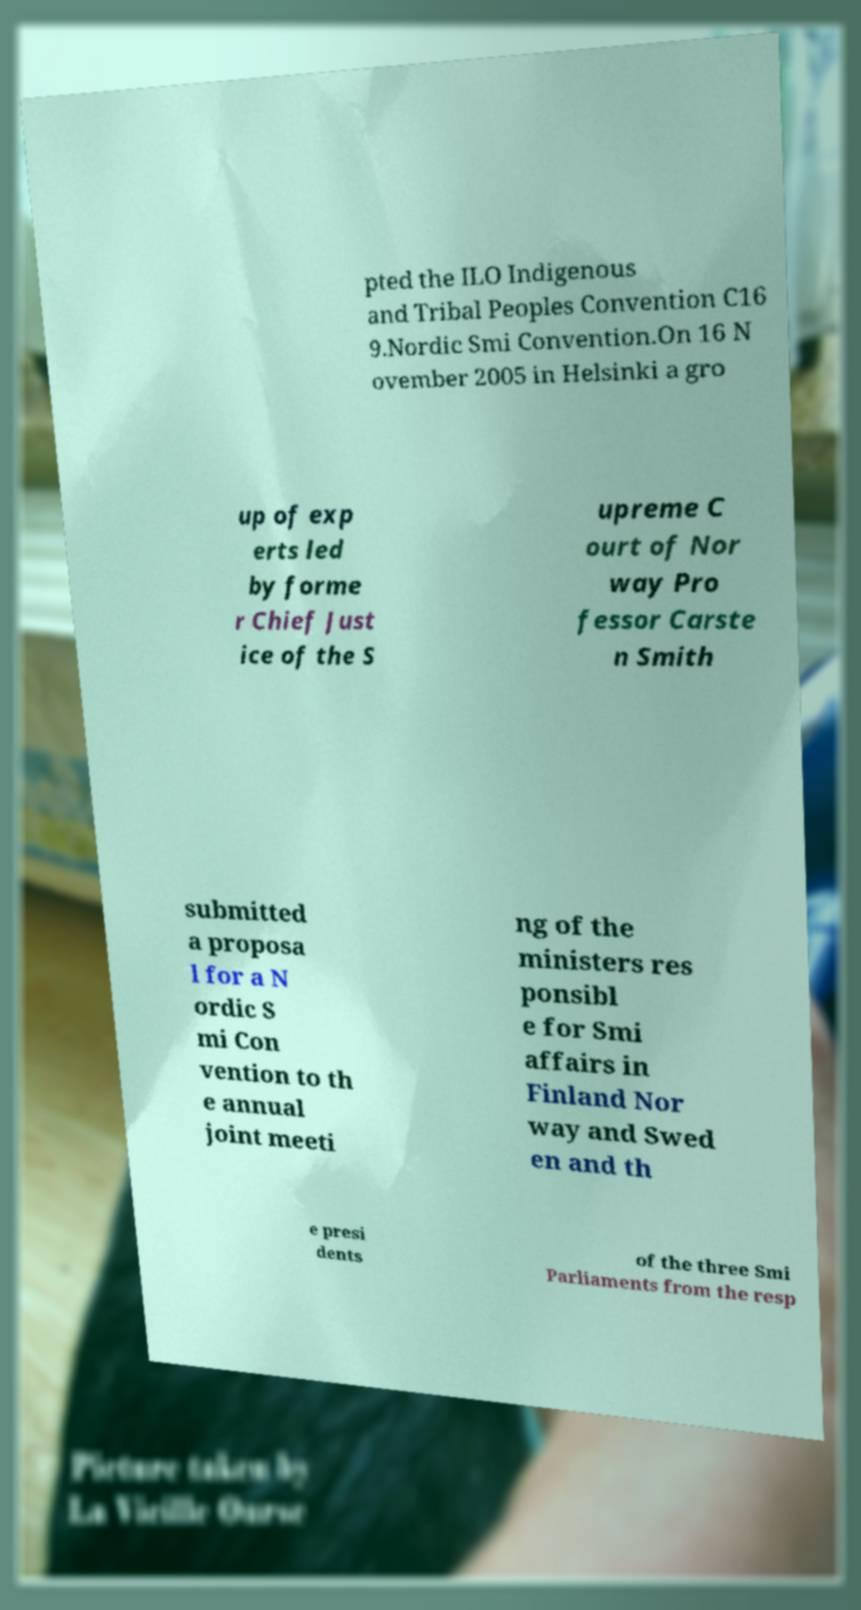There's text embedded in this image that I need extracted. Can you transcribe it verbatim? pted the ILO Indigenous and Tribal Peoples Convention C16 9.Nordic Smi Convention.On 16 N ovember 2005 in Helsinki a gro up of exp erts led by forme r Chief Just ice of the S upreme C ourt of Nor way Pro fessor Carste n Smith submitted a proposa l for a N ordic S mi Con vention to th e annual joint meeti ng of the ministers res ponsibl e for Smi affairs in Finland Nor way and Swed en and th e presi dents of the three Smi Parliaments from the resp 